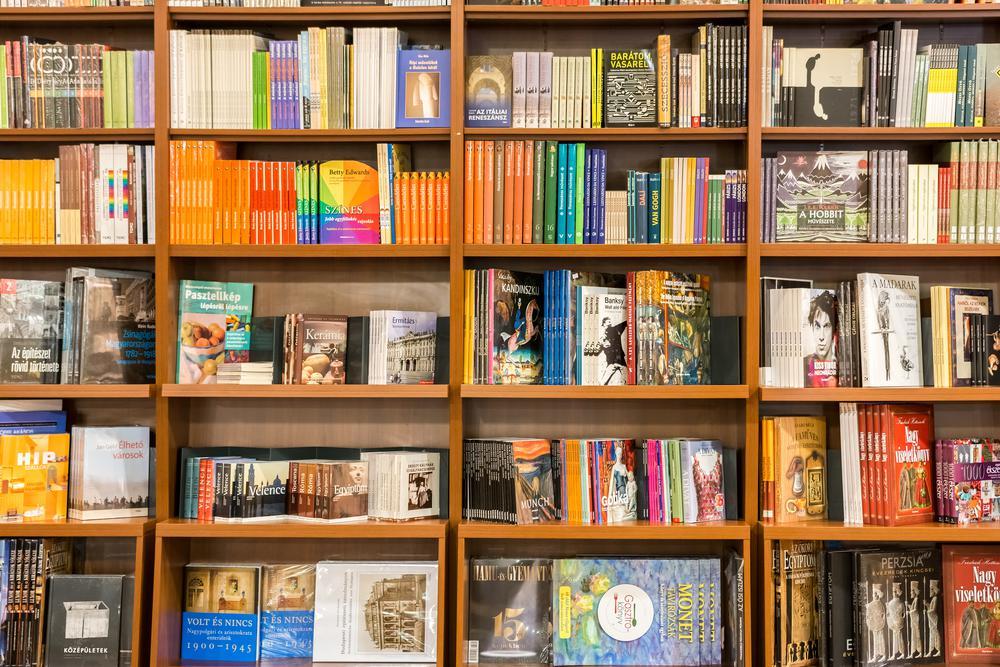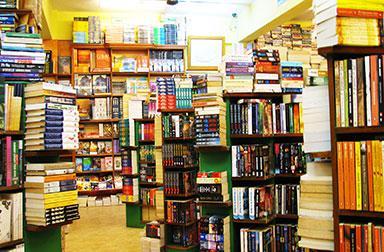The first image is the image on the left, the second image is the image on the right. Evaluate the accuracy of this statement regarding the images: "There are at least 4 people". Is it true? Answer yes or no. No. 